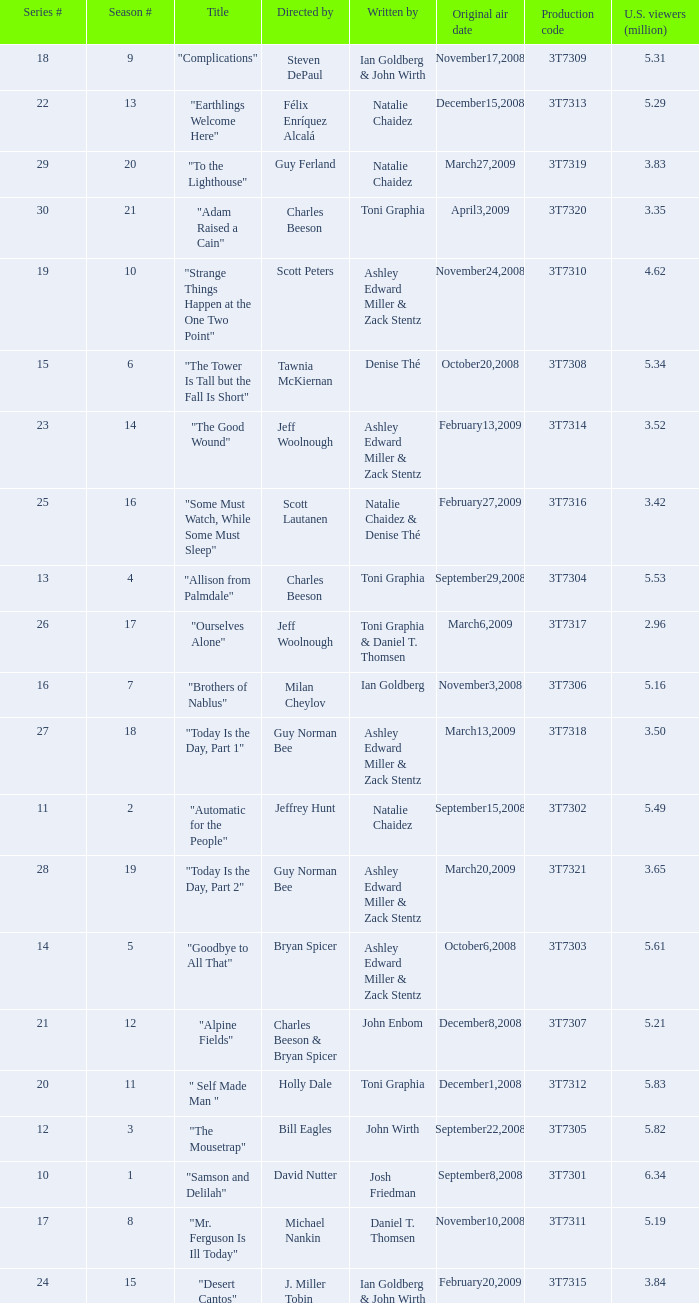How many viewers did the episode directed by David Nutter draw in? 6.34. 